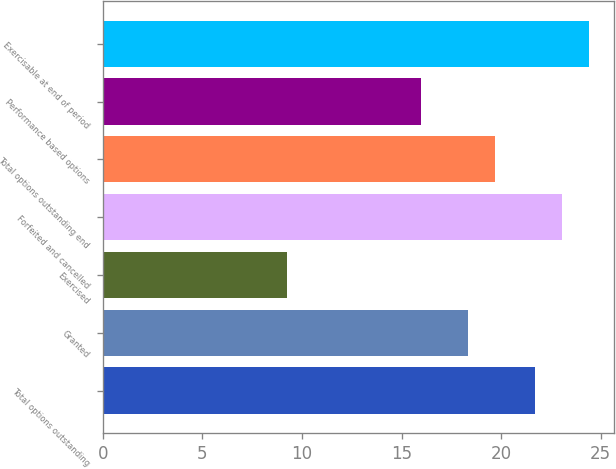Convert chart. <chart><loc_0><loc_0><loc_500><loc_500><bar_chart><fcel>Total options outstanding<fcel>Granted<fcel>Exercised<fcel>Forfeited and cancelled<fcel>Total options outstanding end<fcel>Performance based options<fcel>Exercisable at end of period<nl><fcel>21.71<fcel>18.34<fcel>9.23<fcel>23.07<fcel>19.7<fcel>15.98<fcel>24.43<nl></chart> 